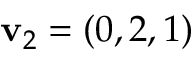Convert formula to latex. <formula><loc_0><loc_0><loc_500><loc_500>v _ { 2 } = ( 0 , 2 , 1 )</formula> 